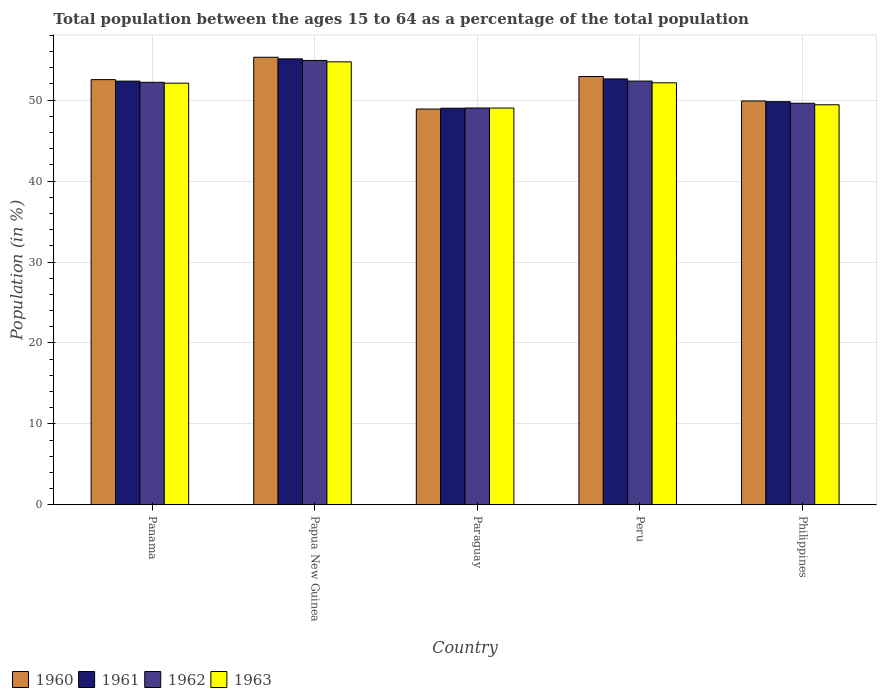How many different coloured bars are there?
Make the answer very short. 4. What is the label of the 1st group of bars from the left?
Your answer should be very brief. Panama. In how many cases, is the number of bars for a given country not equal to the number of legend labels?
Keep it short and to the point. 0. What is the percentage of the population ages 15 to 64 in 1960 in Philippines?
Your answer should be compact. 49.89. Across all countries, what is the maximum percentage of the population ages 15 to 64 in 1963?
Your answer should be compact. 54.72. Across all countries, what is the minimum percentage of the population ages 15 to 64 in 1963?
Your answer should be compact. 49.01. In which country was the percentage of the population ages 15 to 64 in 1963 maximum?
Your answer should be compact. Papua New Guinea. In which country was the percentage of the population ages 15 to 64 in 1963 minimum?
Ensure brevity in your answer.  Paraguay. What is the total percentage of the population ages 15 to 64 in 1960 in the graph?
Your response must be concise. 259.51. What is the difference between the percentage of the population ages 15 to 64 in 1960 in Panama and that in Philippines?
Ensure brevity in your answer.  2.63. What is the difference between the percentage of the population ages 15 to 64 in 1960 in Panama and the percentage of the population ages 15 to 64 in 1963 in Papua New Guinea?
Offer a very short reply. -2.2. What is the average percentage of the population ages 15 to 64 in 1960 per country?
Your response must be concise. 51.9. What is the difference between the percentage of the population ages 15 to 64 of/in 1962 and percentage of the population ages 15 to 64 of/in 1961 in Philippines?
Offer a very short reply. -0.19. In how many countries, is the percentage of the population ages 15 to 64 in 1962 greater than 16?
Your answer should be compact. 5. What is the ratio of the percentage of the population ages 15 to 64 in 1961 in Papua New Guinea to that in Philippines?
Provide a succinct answer. 1.11. Is the percentage of the population ages 15 to 64 in 1962 in Paraguay less than that in Peru?
Your response must be concise. Yes. What is the difference between the highest and the second highest percentage of the population ages 15 to 64 in 1961?
Offer a very short reply. 0.27. What is the difference between the highest and the lowest percentage of the population ages 15 to 64 in 1962?
Give a very brief answer. 5.87. Is the sum of the percentage of the population ages 15 to 64 in 1960 in Panama and Philippines greater than the maximum percentage of the population ages 15 to 64 in 1963 across all countries?
Offer a very short reply. Yes. Is it the case that in every country, the sum of the percentage of the population ages 15 to 64 in 1962 and percentage of the population ages 15 to 64 in 1961 is greater than the sum of percentage of the population ages 15 to 64 in 1960 and percentage of the population ages 15 to 64 in 1963?
Provide a short and direct response. No. What does the 2nd bar from the left in Papua New Guinea represents?
Offer a terse response. 1961. What does the 3rd bar from the right in Paraguay represents?
Provide a succinct answer. 1961. Is it the case that in every country, the sum of the percentage of the population ages 15 to 64 in 1960 and percentage of the population ages 15 to 64 in 1963 is greater than the percentage of the population ages 15 to 64 in 1961?
Your answer should be very brief. Yes. How many bars are there?
Offer a terse response. 20. Are all the bars in the graph horizontal?
Your answer should be very brief. No. Are the values on the major ticks of Y-axis written in scientific E-notation?
Make the answer very short. No. How many legend labels are there?
Provide a short and direct response. 4. What is the title of the graph?
Offer a terse response. Total population between the ages 15 to 64 as a percentage of the total population. What is the label or title of the X-axis?
Your answer should be compact. Country. What is the Population (in %) in 1960 in Panama?
Your answer should be compact. 52.52. What is the Population (in %) of 1961 in Panama?
Your answer should be very brief. 52.34. What is the Population (in %) in 1962 in Panama?
Give a very brief answer. 52.2. What is the Population (in %) of 1963 in Panama?
Give a very brief answer. 52.09. What is the Population (in %) of 1960 in Papua New Guinea?
Offer a very short reply. 55.29. What is the Population (in %) in 1961 in Papua New Guinea?
Offer a very short reply. 55.09. What is the Population (in %) in 1962 in Papua New Guinea?
Provide a short and direct response. 54.89. What is the Population (in %) in 1963 in Papua New Guinea?
Provide a succinct answer. 54.72. What is the Population (in %) of 1960 in Paraguay?
Your response must be concise. 48.9. What is the Population (in %) of 1961 in Paraguay?
Offer a very short reply. 49. What is the Population (in %) of 1962 in Paraguay?
Offer a very short reply. 49.02. What is the Population (in %) of 1963 in Paraguay?
Offer a terse response. 49.01. What is the Population (in %) in 1960 in Peru?
Provide a succinct answer. 52.91. What is the Population (in %) of 1961 in Peru?
Offer a very short reply. 52.61. What is the Population (in %) of 1962 in Peru?
Ensure brevity in your answer.  52.35. What is the Population (in %) of 1963 in Peru?
Offer a very short reply. 52.13. What is the Population (in %) of 1960 in Philippines?
Offer a terse response. 49.89. What is the Population (in %) of 1961 in Philippines?
Offer a very short reply. 49.8. What is the Population (in %) of 1962 in Philippines?
Provide a succinct answer. 49.61. What is the Population (in %) of 1963 in Philippines?
Offer a very short reply. 49.42. Across all countries, what is the maximum Population (in %) in 1960?
Provide a succinct answer. 55.29. Across all countries, what is the maximum Population (in %) in 1961?
Offer a very short reply. 55.09. Across all countries, what is the maximum Population (in %) in 1962?
Offer a very short reply. 54.89. Across all countries, what is the maximum Population (in %) in 1963?
Give a very brief answer. 54.72. Across all countries, what is the minimum Population (in %) of 1960?
Your answer should be very brief. 48.9. Across all countries, what is the minimum Population (in %) in 1961?
Provide a succinct answer. 49. Across all countries, what is the minimum Population (in %) of 1962?
Give a very brief answer. 49.02. Across all countries, what is the minimum Population (in %) of 1963?
Provide a short and direct response. 49.01. What is the total Population (in %) in 1960 in the graph?
Offer a very short reply. 259.51. What is the total Population (in %) in 1961 in the graph?
Make the answer very short. 258.84. What is the total Population (in %) in 1962 in the graph?
Your answer should be very brief. 258.07. What is the total Population (in %) in 1963 in the graph?
Provide a succinct answer. 257.38. What is the difference between the Population (in %) in 1960 in Panama and that in Papua New Guinea?
Ensure brevity in your answer.  -2.76. What is the difference between the Population (in %) of 1961 in Panama and that in Papua New Guinea?
Keep it short and to the point. -2.75. What is the difference between the Population (in %) of 1962 in Panama and that in Papua New Guinea?
Provide a succinct answer. -2.7. What is the difference between the Population (in %) in 1963 in Panama and that in Papua New Guinea?
Make the answer very short. -2.64. What is the difference between the Population (in %) of 1960 in Panama and that in Paraguay?
Provide a succinct answer. 3.63. What is the difference between the Population (in %) in 1961 in Panama and that in Paraguay?
Provide a succinct answer. 3.35. What is the difference between the Population (in %) of 1962 in Panama and that in Paraguay?
Your answer should be compact. 3.17. What is the difference between the Population (in %) of 1963 in Panama and that in Paraguay?
Your response must be concise. 3.07. What is the difference between the Population (in %) of 1960 in Panama and that in Peru?
Offer a terse response. -0.39. What is the difference between the Population (in %) of 1961 in Panama and that in Peru?
Ensure brevity in your answer.  -0.27. What is the difference between the Population (in %) of 1962 in Panama and that in Peru?
Keep it short and to the point. -0.15. What is the difference between the Population (in %) of 1963 in Panama and that in Peru?
Make the answer very short. -0.05. What is the difference between the Population (in %) of 1960 in Panama and that in Philippines?
Keep it short and to the point. 2.63. What is the difference between the Population (in %) of 1961 in Panama and that in Philippines?
Offer a very short reply. 2.54. What is the difference between the Population (in %) of 1962 in Panama and that in Philippines?
Provide a succinct answer. 2.59. What is the difference between the Population (in %) of 1963 in Panama and that in Philippines?
Ensure brevity in your answer.  2.67. What is the difference between the Population (in %) in 1960 in Papua New Guinea and that in Paraguay?
Your answer should be very brief. 6.39. What is the difference between the Population (in %) of 1961 in Papua New Guinea and that in Paraguay?
Ensure brevity in your answer.  6.09. What is the difference between the Population (in %) of 1962 in Papua New Guinea and that in Paraguay?
Provide a short and direct response. 5.87. What is the difference between the Population (in %) of 1963 in Papua New Guinea and that in Paraguay?
Provide a succinct answer. 5.71. What is the difference between the Population (in %) in 1960 in Papua New Guinea and that in Peru?
Make the answer very short. 2.38. What is the difference between the Population (in %) of 1961 in Papua New Guinea and that in Peru?
Your answer should be compact. 2.48. What is the difference between the Population (in %) in 1962 in Papua New Guinea and that in Peru?
Offer a terse response. 2.55. What is the difference between the Population (in %) in 1963 in Papua New Guinea and that in Peru?
Make the answer very short. 2.59. What is the difference between the Population (in %) of 1960 in Papua New Guinea and that in Philippines?
Your response must be concise. 5.4. What is the difference between the Population (in %) of 1961 in Papua New Guinea and that in Philippines?
Keep it short and to the point. 5.29. What is the difference between the Population (in %) in 1962 in Papua New Guinea and that in Philippines?
Offer a very short reply. 5.28. What is the difference between the Population (in %) of 1963 in Papua New Guinea and that in Philippines?
Provide a succinct answer. 5.3. What is the difference between the Population (in %) in 1960 in Paraguay and that in Peru?
Keep it short and to the point. -4.02. What is the difference between the Population (in %) in 1961 in Paraguay and that in Peru?
Your response must be concise. -3.62. What is the difference between the Population (in %) of 1962 in Paraguay and that in Peru?
Provide a short and direct response. -3.32. What is the difference between the Population (in %) of 1963 in Paraguay and that in Peru?
Make the answer very short. -3.12. What is the difference between the Population (in %) of 1960 in Paraguay and that in Philippines?
Offer a very short reply. -0.99. What is the difference between the Population (in %) in 1961 in Paraguay and that in Philippines?
Provide a short and direct response. -0.81. What is the difference between the Population (in %) in 1962 in Paraguay and that in Philippines?
Your response must be concise. -0.59. What is the difference between the Population (in %) in 1963 in Paraguay and that in Philippines?
Offer a very short reply. -0.4. What is the difference between the Population (in %) of 1960 in Peru and that in Philippines?
Offer a terse response. 3.02. What is the difference between the Population (in %) of 1961 in Peru and that in Philippines?
Give a very brief answer. 2.81. What is the difference between the Population (in %) of 1962 in Peru and that in Philippines?
Offer a terse response. 2.74. What is the difference between the Population (in %) of 1963 in Peru and that in Philippines?
Make the answer very short. 2.72. What is the difference between the Population (in %) of 1960 in Panama and the Population (in %) of 1961 in Papua New Guinea?
Give a very brief answer. -2.57. What is the difference between the Population (in %) in 1960 in Panama and the Population (in %) in 1962 in Papua New Guinea?
Make the answer very short. -2.37. What is the difference between the Population (in %) in 1960 in Panama and the Population (in %) in 1963 in Papua New Guinea?
Offer a terse response. -2.2. What is the difference between the Population (in %) of 1961 in Panama and the Population (in %) of 1962 in Papua New Guinea?
Keep it short and to the point. -2.55. What is the difference between the Population (in %) in 1961 in Panama and the Population (in %) in 1963 in Papua New Guinea?
Provide a short and direct response. -2.38. What is the difference between the Population (in %) of 1962 in Panama and the Population (in %) of 1963 in Papua New Guinea?
Ensure brevity in your answer.  -2.52. What is the difference between the Population (in %) in 1960 in Panama and the Population (in %) in 1961 in Paraguay?
Provide a succinct answer. 3.53. What is the difference between the Population (in %) of 1960 in Panama and the Population (in %) of 1962 in Paraguay?
Your response must be concise. 3.5. What is the difference between the Population (in %) in 1960 in Panama and the Population (in %) in 1963 in Paraguay?
Offer a very short reply. 3.51. What is the difference between the Population (in %) of 1961 in Panama and the Population (in %) of 1962 in Paraguay?
Offer a very short reply. 3.32. What is the difference between the Population (in %) of 1961 in Panama and the Population (in %) of 1963 in Paraguay?
Provide a succinct answer. 3.33. What is the difference between the Population (in %) of 1962 in Panama and the Population (in %) of 1963 in Paraguay?
Your response must be concise. 3.18. What is the difference between the Population (in %) of 1960 in Panama and the Population (in %) of 1961 in Peru?
Offer a very short reply. -0.09. What is the difference between the Population (in %) in 1960 in Panama and the Population (in %) in 1962 in Peru?
Your answer should be very brief. 0.18. What is the difference between the Population (in %) of 1960 in Panama and the Population (in %) of 1963 in Peru?
Your answer should be compact. 0.39. What is the difference between the Population (in %) in 1961 in Panama and the Population (in %) in 1962 in Peru?
Offer a very short reply. -0.01. What is the difference between the Population (in %) of 1961 in Panama and the Population (in %) of 1963 in Peru?
Provide a short and direct response. 0.21. What is the difference between the Population (in %) of 1962 in Panama and the Population (in %) of 1963 in Peru?
Keep it short and to the point. 0.06. What is the difference between the Population (in %) in 1960 in Panama and the Population (in %) in 1961 in Philippines?
Keep it short and to the point. 2.72. What is the difference between the Population (in %) of 1960 in Panama and the Population (in %) of 1962 in Philippines?
Make the answer very short. 2.91. What is the difference between the Population (in %) in 1960 in Panama and the Population (in %) in 1963 in Philippines?
Make the answer very short. 3.11. What is the difference between the Population (in %) of 1961 in Panama and the Population (in %) of 1962 in Philippines?
Your response must be concise. 2.73. What is the difference between the Population (in %) of 1961 in Panama and the Population (in %) of 1963 in Philippines?
Give a very brief answer. 2.92. What is the difference between the Population (in %) of 1962 in Panama and the Population (in %) of 1963 in Philippines?
Make the answer very short. 2.78. What is the difference between the Population (in %) of 1960 in Papua New Guinea and the Population (in %) of 1961 in Paraguay?
Your answer should be very brief. 6.29. What is the difference between the Population (in %) of 1960 in Papua New Guinea and the Population (in %) of 1962 in Paraguay?
Offer a terse response. 6.27. What is the difference between the Population (in %) of 1960 in Papua New Guinea and the Population (in %) of 1963 in Paraguay?
Give a very brief answer. 6.27. What is the difference between the Population (in %) in 1961 in Papua New Guinea and the Population (in %) in 1962 in Paraguay?
Provide a succinct answer. 6.07. What is the difference between the Population (in %) of 1961 in Papua New Guinea and the Population (in %) of 1963 in Paraguay?
Your answer should be very brief. 6.08. What is the difference between the Population (in %) in 1962 in Papua New Guinea and the Population (in %) in 1963 in Paraguay?
Ensure brevity in your answer.  5.88. What is the difference between the Population (in %) in 1960 in Papua New Guinea and the Population (in %) in 1961 in Peru?
Offer a very short reply. 2.68. What is the difference between the Population (in %) in 1960 in Papua New Guinea and the Population (in %) in 1962 in Peru?
Make the answer very short. 2.94. What is the difference between the Population (in %) of 1960 in Papua New Guinea and the Population (in %) of 1963 in Peru?
Offer a terse response. 3.15. What is the difference between the Population (in %) of 1961 in Papua New Guinea and the Population (in %) of 1962 in Peru?
Your answer should be very brief. 2.74. What is the difference between the Population (in %) of 1961 in Papua New Guinea and the Population (in %) of 1963 in Peru?
Your answer should be compact. 2.96. What is the difference between the Population (in %) in 1962 in Papua New Guinea and the Population (in %) in 1963 in Peru?
Your response must be concise. 2.76. What is the difference between the Population (in %) in 1960 in Papua New Guinea and the Population (in %) in 1961 in Philippines?
Keep it short and to the point. 5.49. What is the difference between the Population (in %) in 1960 in Papua New Guinea and the Population (in %) in 1962 in Philippines?
Offer a terse response. 5.68. What is the difference between the Population (in %) in 1960 in Papua New Guinea and the Population (in %) in 1963 in Philippines?
Give a very brief answer. 5.87. What is the difference between the Population (in %) of 1961 in Papua New Guinea and the Population (in %) of 1962 in Philippines?
Give a very brief answer. 5.48. What is the difference between the Population (in %) in 1961 in Papua New Guinea and the Population (in %) in 1963 in Philippines?
Provide a succinct answer. 5.67. What is the difference between the Population (in %) in 1962 in Papua New Guinea and the Population (in %) in 1963 in Philippines?
Offer a terse response. 5.47. What is the difference between the Population (in %) in 1960 in Paraguay and the Population (in %) in 1961 in Peru?
Offer a terse response. -3.72. What is the difference between the Population (in %) in 1960 in Paraguay and the Population (in %) in 1962 in Peru?
Offer a terse response. -3.45. What is the difference between the Population (in %) of 1960 in Paraguay and the Population (in %) of 1963 in Peru?
Your answer should be compact. -3.24. What is the difference between the Population (in %) in 1961 in Paraguay and the Population (in %) in 1962 in Peru?
Your answer should be very brief. -3.35. What is the difference between the Population (in %) in 1961 in Paraguay and the Population (in %) in 1963 in Peru?
Provide a succinct answer. -3.14. What is the difference between the Population (in %) in 1962 in Paraguay and the Population (in %) in 1963 in Peru?
Offer a terse response. -3.11. What is the difference between the Population (in %) of 1960 in Paraguay and the Population (in %) of 1961 in Philippines?
Provide a succinct answer. -0.91. What is the difference between the Population (in %) of 1960 in Paraguay and the Population (in %) of 1962 in Philippines?
Ensure brevity in your answer.  -0.71. What is the difference between the Population (in %) of 1960 in Paraguay and the Population (in %) of 1963 in Philippines?
Offer a terse response. -0.52. What is the difference between the Population (in %) in 1961 in Paraguay and the Population (in %) in 1962 in Philippines?
Offer a terse response. -0.61. What is the difference between the Population (in %) of 1961 in Paraguay and the Population (in %) of 1963 in Philippines?
Provide a short and direct response. -0.42. What is the difference between the Population (in %) in 1962 in Paraguay and the Population (in %) in 1963 in Philippines?
Your response must be concise. -0.4. What is the difference between the Population (in %) in 1960 in Peru and the Population (in %) in 1961 in Philippines?
Ensure brevity in your answer.  3.11. What is the difference between the Population (in %) in 1960 in Peru and the Population (in %) in 1962 in Philippines?
Your response must be concise. 3.3. What is the difference between the Population (in %) of 1960 in Peru and the Population (in %) of 1963 in Philippines?
Make the answer very short. 3.49. What is the difference between the Population (in %) of 1961 in Peru and the Population (in %) of 1962 in Philippines?
Your answer should be compact. 3. What is the difference between the Population (in %) of 1961 in Peru and the Population (in %) of 1963 in Philippines?
Ensure brevity in your answer.  3.19. What is the difference between the Population (in %) of 1962 in Peru and the Population (in %) of 1963 in Philippines?
Keep it short and to the point. 2.93. What is the average Population (in %) in 1960 per country?
Provide a short and direct response. 51.9. What is the average Population (in %) in 1961 per country?
Ensure brevity in your answer.  51.77. What is the average Population (in %) of 1962 per country?
Give a very brief answer. 51.61. What is the average Population (in %) of 1963 per country?
Your response must be concise. 51.48. What is the difference between the Population (in %) of 1960 and Population (in %) of 1961 in Panama?
Keep it short and to the point. 0.18. What is the difference between the Population (in %) of 1960 and Population (in %) of 1962 in Panama?
Your answer should be very brief. 0.33. What is the difference between the Population (in %) in 1960 and Population (in %) in 1963 in Panama?
Provide a succinct answer. 0.44. What is the difference between the Population (in %) in 1961 and Population (in %) in 1962 in Panama?
Your answer should be compact. 0.15. What is the difference between the Population (in %) in 1961 and Population (in %) in 1963 in Panama?
Keep it short and to the point. 0.26. What is the difference between the Population (in %) of 1962 and Population (in %) of 1963 in Panama?
Provide a short and direct response. 0.11. What is the difference between the Population (in %) in 1960 and Population (in %) in 1961 in Papua New Guinea?
Provide a succinct answer. 0.2. What is the difference between the Population (in %) of 1960 and Population (in %) of 1962 in Papua New Guinea?
Offer a terse response. 0.4. What is the difference between the Population (in %) of 1960 and Population (in %) of 1963 in Papua New Guinea?
Ensure brevity in your answer.  0.57. What is the difference between the Population (in %) in 1961 and Population (in %) in 1962 in Papua New Guinea?
Provide a short and direct response. 0.2. What is the difference between the Population (in %) in 1961 and Population (in %) in 1963 in Papua New Guinea?
Offer a very short reply. 0.37. What is the difference between the Population (in %) in 1962 and Population (in %) in 1963 in Papua New Guinea?
Your answer should be compact. 0.17. What is the difference between the Population (in %) in 1960 and Population (in %) in 1961 in Paraguay?
Offer a terse response. -0.1. What is the difference between the Population (in %) in 1960 and Population (in %) in 1962 in Paraguay?
Offer a very short reply. -0.13. What is the difference between the Population (in %) of 1960 and Population (in %) of 1963 in Paraguay?
Offer a very short reply. -0.12. What is the difference between the Population (in %) in 1961 and Population (in %) in 1962 in Paraguay?
Give a very brief answer. -0.03. What is the difference between the Population (in %) of 1961 and Population (in %) of 1963 in Paraguay?
Ensure brevity in your answer.  -0.02. What is the difference between the Population (in %) in 1962 and Population (in %) in 1963 in Paraguay?
Make the answer very short. 0.01. What is the difference between the Population (in %) in 1960 and Population (in %) in 1961 in Peru?
Your answer should be compact. 0.3. What is the difference between the Population (in %) in 1960 and Population (in %) in 1962 in Peru?
Provide a short and direct response. 0.56. What is the difference between the Population (in %) in 1960 and Population (in %) in 1963 in Peru?
Keep it short and to the point. 0.78. What is the difference between the Population (in %) in 1961 and Population (in %) in 1962 in Peru?
Your answer should be very brief. 0.26. What is the difference between the Population (in %) in 1961 and Population (in %) in 1963 in Peru?
Keep it short and to the point. 0.48. What is the difference between the Population (in %) of 1962 and Population (in %) of 1963 in Peru?
Ensure brevity in your answer.  0.21. What is the difference between the Population (in %) in 1960 and Population (in %) in 1961 in Philippines?
Ensure brevity in your answer.  0.09. What is the difference between the Population (in %) of 1960 and Population (in %) of 1962 in Philippines?
Ensure brevity in your answer.  0.28. What is the difference between the Population (in %) in 1960 and Population (in %) in 1963 in Philippines?
Offer a terse response. 0.47. What is the difference between the Population (in %) in 1961 and Population (in %) in 1962 in Philippines?
Give a very brief answer. 0.19. What is the difference between the Population (in %) of 1961 and Population (in %) of 1963 in Philippines?
Ensure brevity in your answer.  0.38. What is the difference between the Population (in %) in 1962 and Population (in %) in 1963 in Philippines?
Give a very brief answer. 0.19. What is the ratio of the Population (in %) of 1961 in Panama to that in Papua New Guinea?
Your answer should be very brief. 0.95. What is the ratio of the Population (in %) in 1962 in Panama to that in Papua New Guinea?
Ensure brevity in your answer.  0.95. What is the ratio of the Population (in %) in 1963 in Panama to that in Papua New Guinea?
Give a very brief answer. 0.95. What is the ratio of the Population (in %) of 1960 in Panama to that in Paraguay?
Offer a terse response. 1.07. What is the ratio of the Population (in %) of 1961 in Panama to that in Paraguay?
Provide a short and direct response. 1.07. What is the ratio of the Population (in %) in 1962 in Panama to that in Paraguay?
Make the answer very short. 1.06. What is the ratio of the Population (in %) in 1963 in Panama to that in Paraguay?
Your response must be concise. 1.06. What is the ratio of the Population (in %) in 1961 in Panama to that in Peru?
Give a very brief answer. 0.99. What is the ratio of the Population (in %) of 1963 in Panama to that in Peru?
Your response must be concise. 1. What is the ratio of the Population (in %) in 1960 in Panama to that in Philippines?
Offer a very short reply. 1.05. What is the ratio of the Population (in %) of 1961 in Panama to that in Philippines?
Your answer should be compact. 1.05. What is the ratio of the Population (in %) in 1962 in Panama to that in Philippines?
Provide a succinct answer. 1.05. What is the ratio of the Population (in %) of 1963 in Panama to that in Philippines?
Make the answer very short. 1.05. What is the ratio of the Population (in %) of 1960 in Papua New Guinea to that in Paraguay?
Offer a terse response. 1.13. What is the ratio of the Population (in %) in 1961 in Papua New Guinea to that in Paraguay?
Offer a very short reply. 1.12. What is the ratio of the Population (in %) of 1962 in Papua New Guinea to that in Paraguay?
Provide a succinct answer. 1.12. What is the ratio of the Population (in %) of 1963 in Papua New Guinea to that in Paraguay?
Keep it short and to the point. 1.12. What is the ratio of the Population (in %) of 1960 in Papua New Guinea to that in Peru?
Your answer should be very brief. 1.04. What is the ratio of the Population (in %) of 1961 in Papua New Guinea to that in Peru?
Make the answer very short. 1.05. What is the ratio of the Population (in %) of 1962 in Papua New Guinea to that in Peru?
Keep it short and to the point. 1.05. What is the ratio of the Population (in %) in 1963 in Papua New Guinea to that in Peru?
Offer a very short reply. 1.05. What is the ratio of the Population (in %) in 1960 in Papua New Guinea to that in Philippines?
Keep it short and to the point. 1.11. What is the ratio of the Population (in %) in 1961 in Papua New Guinea to that in Philippines?
Make the answer very short. 1.11. What is the ratio of the Population (in %) in 1962 in Papua New Guinea to that in Philippines?
Your answer should be very brief. 1.11. What is the ratio of the Population (in %) of 1963 in Papua New Guinea to that in Philippines?
Offer a terse response. 1.11. What is the ratio of the Population (in %) in 1960 in Paraguay to that in Peru?
Keep it short and to the point. 0.92. What is the ratio of the Population (in %) in 1961 in Paraguay to that in Peru?
Give a very brief answer. 0.93. What is the ratio of the Population (in %) in 1962 in Paraguay to that in Peru?
Your answer should be compact. 0.94. What is the ratio of the Population (in %) in 1963 in Paraguay to that in Peru?
Keep it short and to the point. 0.94. What is the ratio of the Population (in %) of 1960 in Paraguay to that in Philippines?
Give a very brief answer. 0.98. What is the ratio of the Population (in %) of 1961 in Paraguay to that in Philippines?
Ensure brevity in your answer.  0.98. What is the ratio of the Population (in %) in 1963 in Paraguay to that in Philippines?
Offer a very short reply. 0.99. What is the ratio of the Population (in %) in 1960 in Peru to that in Philippines?
Keep it short and to the point. 1.06. What is the ratio of the Population (in %) of 1961 in Peru to that in Philippines?
Ensure brevity in your answer.  1.06. What is the ratio of the Population (in %) in 1962 in Peru to that in Philippines?
Keep it short and to the point. 1.06. What is the ratio of the Population (in %) of 1963 in Peru to that in Philippines?
Keep it short and to the point. 1.05. What is the difference between the highest and the second highest Population (in %) in 1960?
Offer a very short reply. 2.38. What is the difference between the highest and the second highest Population (in %) of 1961?
Your answer should be very brief. 2.48. What is the difference between the highest and the second highest Population (in %) in 1962?
Give a very brief answer. 2.55. What is the difference between the highest and the second highest Population (in %) in 1963?
Offer a terse response. 2.59. What is the difference between the highest and the lowest Population (in %) in 1960?
Provide a succinct answer. 6.39. What is the difference between the highest and the lowest Population (in %) in 1961?
Keep it short and to the point. 6.09. What is the difference between the highest and the lowest Population (in %) in 1962?
Keep it short and to the point. 5.87. What is the difference between the highest and the lowest Population (in %) in 1963?
Make the answer very short. 5.71. 